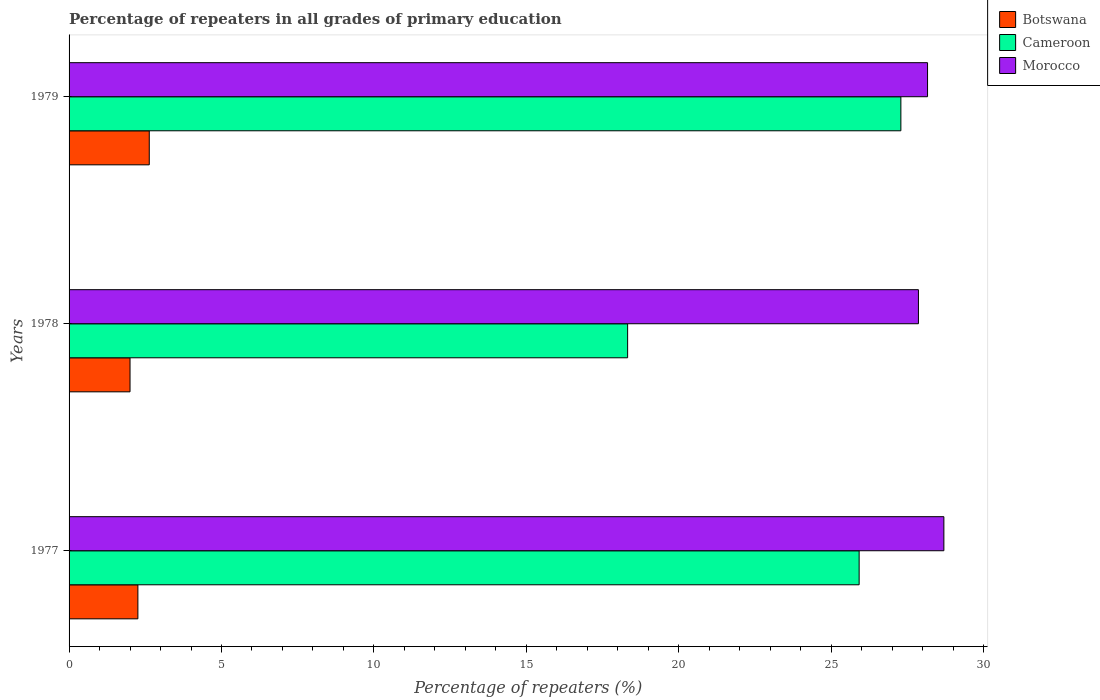Are the number of bars on each tick of the Y-axis equal?
Provide a succinct answer. Yes. How many bars are there on the 1st tick from the top?
Your answer should be compact. 3. How many bars are there on the 2nd tick from the bottom?
Your response must be concise. 3. What is the label of the 2nd group of bars from the top?
Keep it short and to the point. 1978. In how many cases, is the number of bars for a given year not equal to the number of legend labels?
Ensure brevity in your answer.  0. What is the percentage of repeaters in Morocco in 1979?
Offer a very short reply. 28.16. Across all years, what is the maximum percentage of repeaters in Cameroon?
Your answer should be very brief. 27.29. Across all years, what is the minimum percentage of repeaters in Cameroon?
Offer a very short reply. 18.32. In which year was the percentage of repeaters in Cameroon minimum?
Your answer should be very brief. 1978. What is the total percentage of repeaters in Cameroon in the graph?
Ensure brevity in your answer.  71.52. What is the difference between the percentage of repeaters in Morocco in 1977 and that in 1979?
Offer a very short reply. 0.54. What is the difference between the percentage of repeaters in Morocco in 1979 and the percentage of repeaters in Cameroon in 1978?
Give a very brief answer. 9.84. What is the average percentage of repeaters in Botswana per year?
Offer a very short reply. 2.3. In the year 1979, what is the difference between the percentage of repeaters in Cameroon and percentage of repeaters in Morocco?
Offer a very short reply. -0.88. What is the ratio of the percentage of repeaters in Botswana in 1977 to that in 1979?
Your answer should be very brief. 0.86. Is the percentage of repeaters in Botswana in 1978 less than that in 1979?
Make the answer very short. Yes. What is the difference between the highest and the second highest percentage of repeaters in Morocco?
Your response must be concise. 0.54. What is the difference between the highest and the lowest percentage of repeaters in Cameroon?
Your response must be concise. 8.96. Is the sum of the percentage of repeaters in Cameroon in 1977 and 1978 greater than the maximum percentage of repeaters in Morocco across all years?
Provide a short and direct response. Yes. What does the 1st bar from the top in 1977 represents?
Provide a succinct answer. Morocco. What does the 2nd bar from the bottom in 1979 represents?
Ensure brevity in your answer.  Cameroon. How many bars are there?
Your answer should be very brief. 9. Are all the bars in the graph horizontal?
Offer a very short reply. Yes. Are the values on the major ticks of X-axis written in scientific E-notation?
Ensure brevity in your answer.  No. Where does the legend appear in the graph?
Give a very brief answer. Top right. How many legend labels are there?
Make the answer very short. 3. What is the title of the graph?
Make the answer very short. Percentage of repeaters in all grades of primary education. Does "Albania" appear as one of the legend labels in the graph?
Give a very brief answer. No. What is the label or title of the X-axis?
Your response must be concise. Percentage of repeaters (%). What is the label or title of the Y-axis?
Offer a terse response. Years. What is the Percentage of repeaters (%) of Botswana in 1977?
Make the answer very short. 2.26. What is the Percentage of repeaters (%) of Cameroon in 1977?
Provide a short and direct response. 25.92. What is the Percentage of repeaters (%) of Morocco in 1977?
Give a very brief answer. 28.7. What is the Percentage of repeaters (%) of Botswana in 1978?
Offer a terse response. 2. What is the Percentage of repeaters (%) in Cameroon in 1978?
Keep it short and to the point. 18.32. What is the Percentage of repeaters (%) of Morocco in 1978?
Offer a very short reply. 27.86. What is the Percentage of repeaters (%) of Botswana in 1979?
Provide a succinct answer. 2.63. What is the Percentage of repeaters (%) of Cameroon in 1979?
Make the answer very short. 27.29. What is the Percentage of repeaters (%) of Morocco in 1979?
Offer a terse response. 28.16. Across all years, what is the maximum Percentage of repeaters (%) in Botswana?
Your answer should be compact. 2.63. Across all years, what is the maximum Percentage of repeaters (%) in Cameroon?
Keep it short and to the point. 27.29. Across all years, what is the maximum Percentage of repeaters (%) in Morocco?
Ensure brevity in your answer.  28.7. Across all years, what is the minimum Percentage of repeaters (%) of Botswana?
Keep it short and to the point. 2. Across all years, what is the minimum Percentage of repeaters (%) in Cameroon?
Your answer should be compact. 18.32. Across all years, what is the minimum Percentage of repeaters (%) in Morocco?
Offer a terse response. 27.86. What is the total Percentage of repeaters (%) of Botswana in the graph?
Ensure brevity in your answer.  6.89. What is the total Percentage of repeaters (%) in Cameroon in the graph?
Make the answer very short. 71.52. What is the total Percentage of repeaters (%) in Morocco in the graph?
Offer a terse response. 84.72. What is the difference between the Percentage of repeaters (%) in Botswana in 1977 and that in 1978?
Your answer should be very brief. 0.26. What is the difference between the Percentage of repeaters (%) in Cameroon in 1977 and that in 1978?
Your answer should be very brief. 7.59. What is the difference between the Percentage of repeaters (%) in Morocco in 1977 and that in 1978?
Your answer should be very brief. 0.83. What is the difference between the Percentage of repeaters (%) in Botswana in 1977 and that in 1979?
Keep it short and to the point. -0.37. What is the difference between the Percentage of repeaters (%) of Cameroon in 1977 and that in 1979?
Offer a terse response. -1.37. What is the difference between the Percentage of repeaters (%) of Morocco in 1977 and that in 1979?
Ensure brevity in your answer.  0.54. What is the difference between the Percentage of repeaters (%) of Botswana in 1978 and that in 1979?
Your answer should be very brief. -0.63. What is the difference between the Percentage of repeaters (%) in Cameroon in 1978 and that in 1979?
Provide a succinct answer. -8.96. What is the difference between the Percentage of repeaters (%) of Morocco in 1978 and that in 1979?
Provide a short and direct response. -0.3. What is the difference between the Percentage of repeaters (%) of Botswana in 1977 and the Percentage of repeaters (%) of Cameroon in 1978?
Your answer should be very brief. -16.06. What is the difference between the Percentage of repeaters (%) in Botswana in 1977 and the Percentage of repeaters (%) in Morocco in 1978?
Make the answer very short. -25.6. What is the difference between the Percentage of repeaters (%) in Cameroon in 1977 and the Percentage of repeaters (%) in Morocco in 1978?
Make the answer very short. -1.95. What is the difference between the Percentage of repeaters (%) in Botswana in 1977 and the Percentage of repeaters (%) in Cameroon in 1979?
Offer a terse response. -25.03. What is the difference between the Percentage of repeaters (%) of Botswana in 1977 and the Percentage of repeaters (%) of Morocco in 1979?
Your answer should be very brief. -25.9. What is the difference between the Percentage of repeaters (%) of Cameroon in 1977 and the Percentage of repeaters (%) of Morocco in 1979?
Your answer should be compact. -2.24. What is the difference between the Percentage of repeaters (%) in Botswana in 1978 and the Percentage of repeaters (%) in Cameroon in 1979?
Provide a succinct answer. -25.29. What is the difference between the Percentage of repeaters (%) of Botswana in 1978 and the Percentage of repeaters (%) of Morocco in 1979?
Provide a short and direct response. -26.16. What is the difference between the Percentage of repeaters (%) of Cameroon in 1978 and the Percentage of repeaters (%) of Morocco in 1979?
Give a very brief answer. -9.84. What is the average Percentage of repeaters (%) of Botswana per year?
Provide a short and direct response. 2.3. What is the average Percentage of repeaters (%) in Cameroon per year?
Your response must be concise. 23.84. What is the average Percentage of repeaters (%) of Morocco per year?
Offer a terse response. 28.24. In the year 1977, what is the difference between the Percentage of repeaters (%) in Botswana and Percentage of repeaters (%) in Cameroon?
Keep it short and to the point. -23.66. In the year 1977, what is the difference between the Percentage of repeaters (%) in Botswana and Percentage of repeaters (%) in Morocco?
Offer a very short reply. -26.44. In the year 1977, what is the difference between the Percentage of repeaters (%) of Cameroon and Percentage of repeaters (%) of Morocco?
Offer a terse response. -2.78. In the year 1978, what is the difference between the Percentage of repeaters (%) in Botswana and Percentage of repeaters (%) in Cameroon?
Give a very brief answer. -16.32. In the year 1978, what is the difference between the Percentage of repeaters (%) in Botswana and Percentage of repeaters (%) in Morocco?
Make the answer very short. -25.86. In the year 1978, what is the difference between the Percentage of repeaters (%) of Cameroon and Percentage of repeaters (%) of Morocco?
Ensure brevity in your answer.  -9.54. In the year 1979, what is the difference between the Percentage of repeaters (%) of Botswana and Percentage of repeaters (%) of Cameroon?
Your response must be concise. -24.65. In the year 1979, what is the difference between the Percentage of repeaters (%) of Botswana and Percentage of repeaters (%) of Morocco?
Your response must be concise. -25.53. In the year 1979, what is the difference between the Percentage of repeaters (%) in Cameroon and Percentage of repeaters (%) in Morocco?
Offer a very short reply. -0.88. What is the ratio of the Percentage of repeaters (%) in Botswana in 1977 to that in 1978?
Your answer should be compact. 1.13. What is the ratio of the Percentage of repeaters (%) of Cameroon in 1977 to that in 1978?
Ensure brevity in your answer.  1.41. What is the ratio of the Percentage of repeaters (%) of Morocco in 1977 to that in 1978?
Give a very brief answer. 1.03. What is the ratio of the Percentage of repeaters (%) of Botswana in 1977 to that in 1979?
Give a very brief answer. 0.86. What is the ratio of the Percentage of repeaters (%) in Cameroon in 1977 to that in 1979?
Provide a short and direct response. 0.95. What is the ratio of the Percentage of repeaters (%) of Morocco in 1977 to that in 1979?
Provide a short and direct response. 1.02. What is the ratio of the Percentage of repeaters (%) of Botswana in 1978 to that in 1979?
Keep it short and to the point. 0.76. What is the ratio of the Percentage of repeaters (%) of Cameroon in 1978 to that in 1979?
Offer a terse response. 0.67. What is the difference between the highest and the second highest Percentage of repeaters (%) in Botswana?
Keep it short and to the point. 0.37. What is the difference between the highest and the second highest Percentage of repeaters (%) of Cameroon?
Provide a succinct answer. 1.37. What is the difference between the highest and the second highest Percentage of repeaters (%) of Morocco?
Ensure brevity in your answer.  0.54. What is the difference between the highest and the lowest Percentage of repeaters (%) of Botswana?
Provide a succinct answer. 0.63. What is the difference between the highest and the lowest Percentage of repeaters (%) in Cameroon?
Ensure brevity in your answer.  8.96. What is the difference between the highest and the lowest Percentage of repeaters (%) in Morocco?
Give a very brief answer. 0.83. 